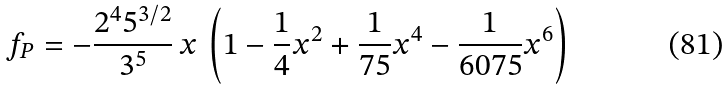<formula> <loc_0><loc_0><loc_500><loc_500>f _ { P } = - { \frac { 2 ^ { 4 } 5 ^ { 3 / 2 } } { 3 ^ { 5 } } } \, x \, \left ( 1 - { \frac { 1 } { 4 } } x ^ { 2 } + { \frac { 1 } { 7 5 } } x ^ { 4 } - { \frac { 1 } { 6 0 7 5 } } x ^ { 6 } \right ) \,</formula> 